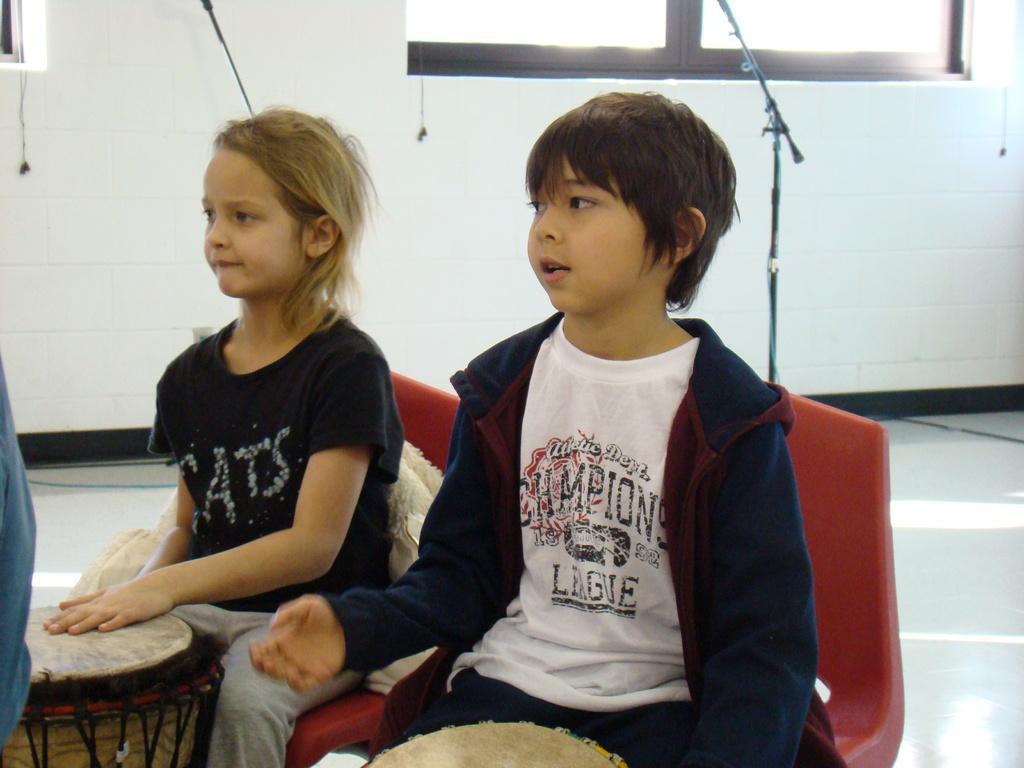Could you give a brief overview of what you see in this image? This image consists of two chairs, mic stands, windows, drums. Two children are sitting on two chairs. Windows are on the top. They are wearing black color dress. 